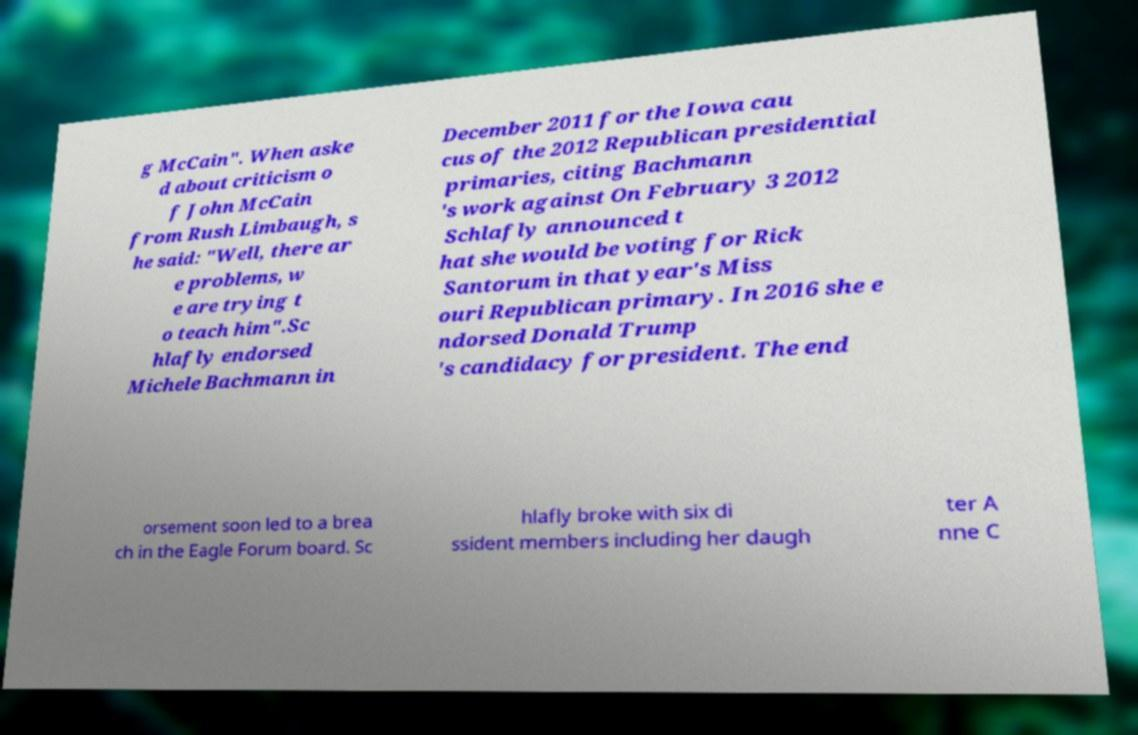Can you read and provide the text displayed in the image?This photo seems to have some interesting text. Can you extract and type it out for me? g McCain". When aske d about criticism o f John McCain from Rush Limbaugh, s he said: "Well, there ar e problems, w e are trying t o teach him".Sc hlafly endorsed Michele Bachmann in December 2011 for the Iowa cau cus of the 2012 Republican presidential primaries, citing Bachmann 's work against On February 3 2012 Schlafly announced t hat she would be voting for Rick Santorum in that year's Miss ouri Republican primary. In 2016 she e ndorsed Donald Trump 's candidacy for president. The end orsement soon led to a brea ch in the Eagle Forum board. Sc hlafly broke with six di ssident members including her daugh ter A nne C 